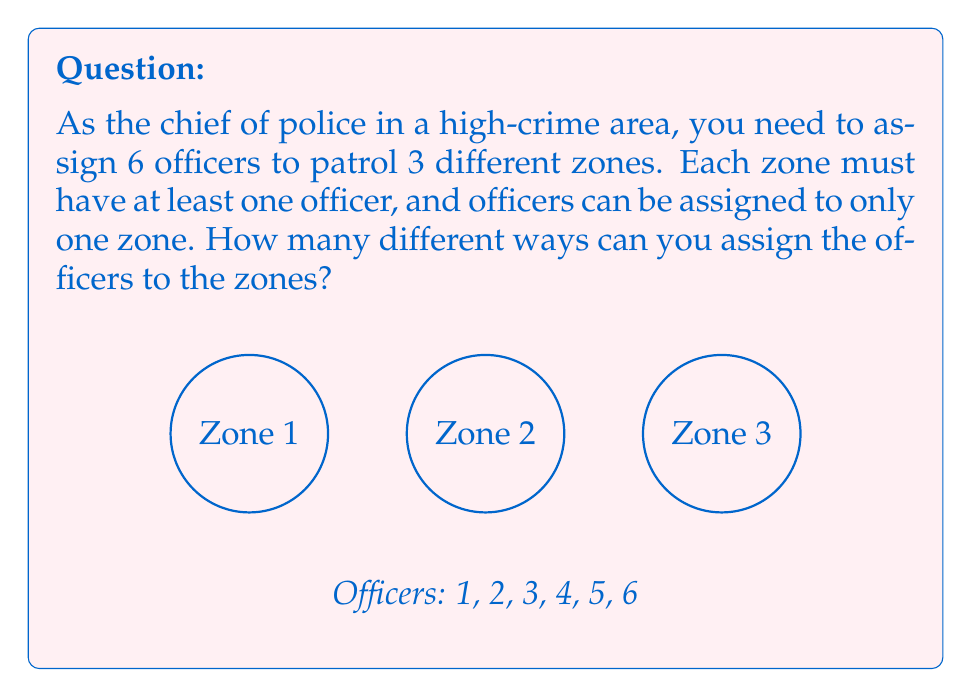Help me with this question. Let's approach this step-by-step using the stars and bars method:

1) We need to distribute 6 officers (objects) into 3 zones (groups), with each zone having at least one officer.

2) To ensure each zone has at least one officer, we can first assign one officer to each zone. This leaves us with 3 officers to distribute freely.

3) Now we have a problem of distributing 3 identical objects (remaining officers) into 3 distinct groups (zones).

4) The stars and bars formula for this scenario is:

   $${n+k-1 \choose k-1}$$

   Where $n$ is the number of identical objects and $k$ is the number of distinct groups.

5) In our case, $n = 3$ (remaining officers) and $k = 3$ (zones).

6) Plugging these values into the formula:

   $${3+3-1 \choose 3-1} = {5 \choose 2}$$

7) We can calculate this:

   $${5 \choose 2} = \frac{5!}{2!(5-2)!} = \frac{5 \cdot 4}{2 \cdot 1} = 10$$

Therefore, there are 10 different ways to assign the officers to the zones.
Answer: 10 